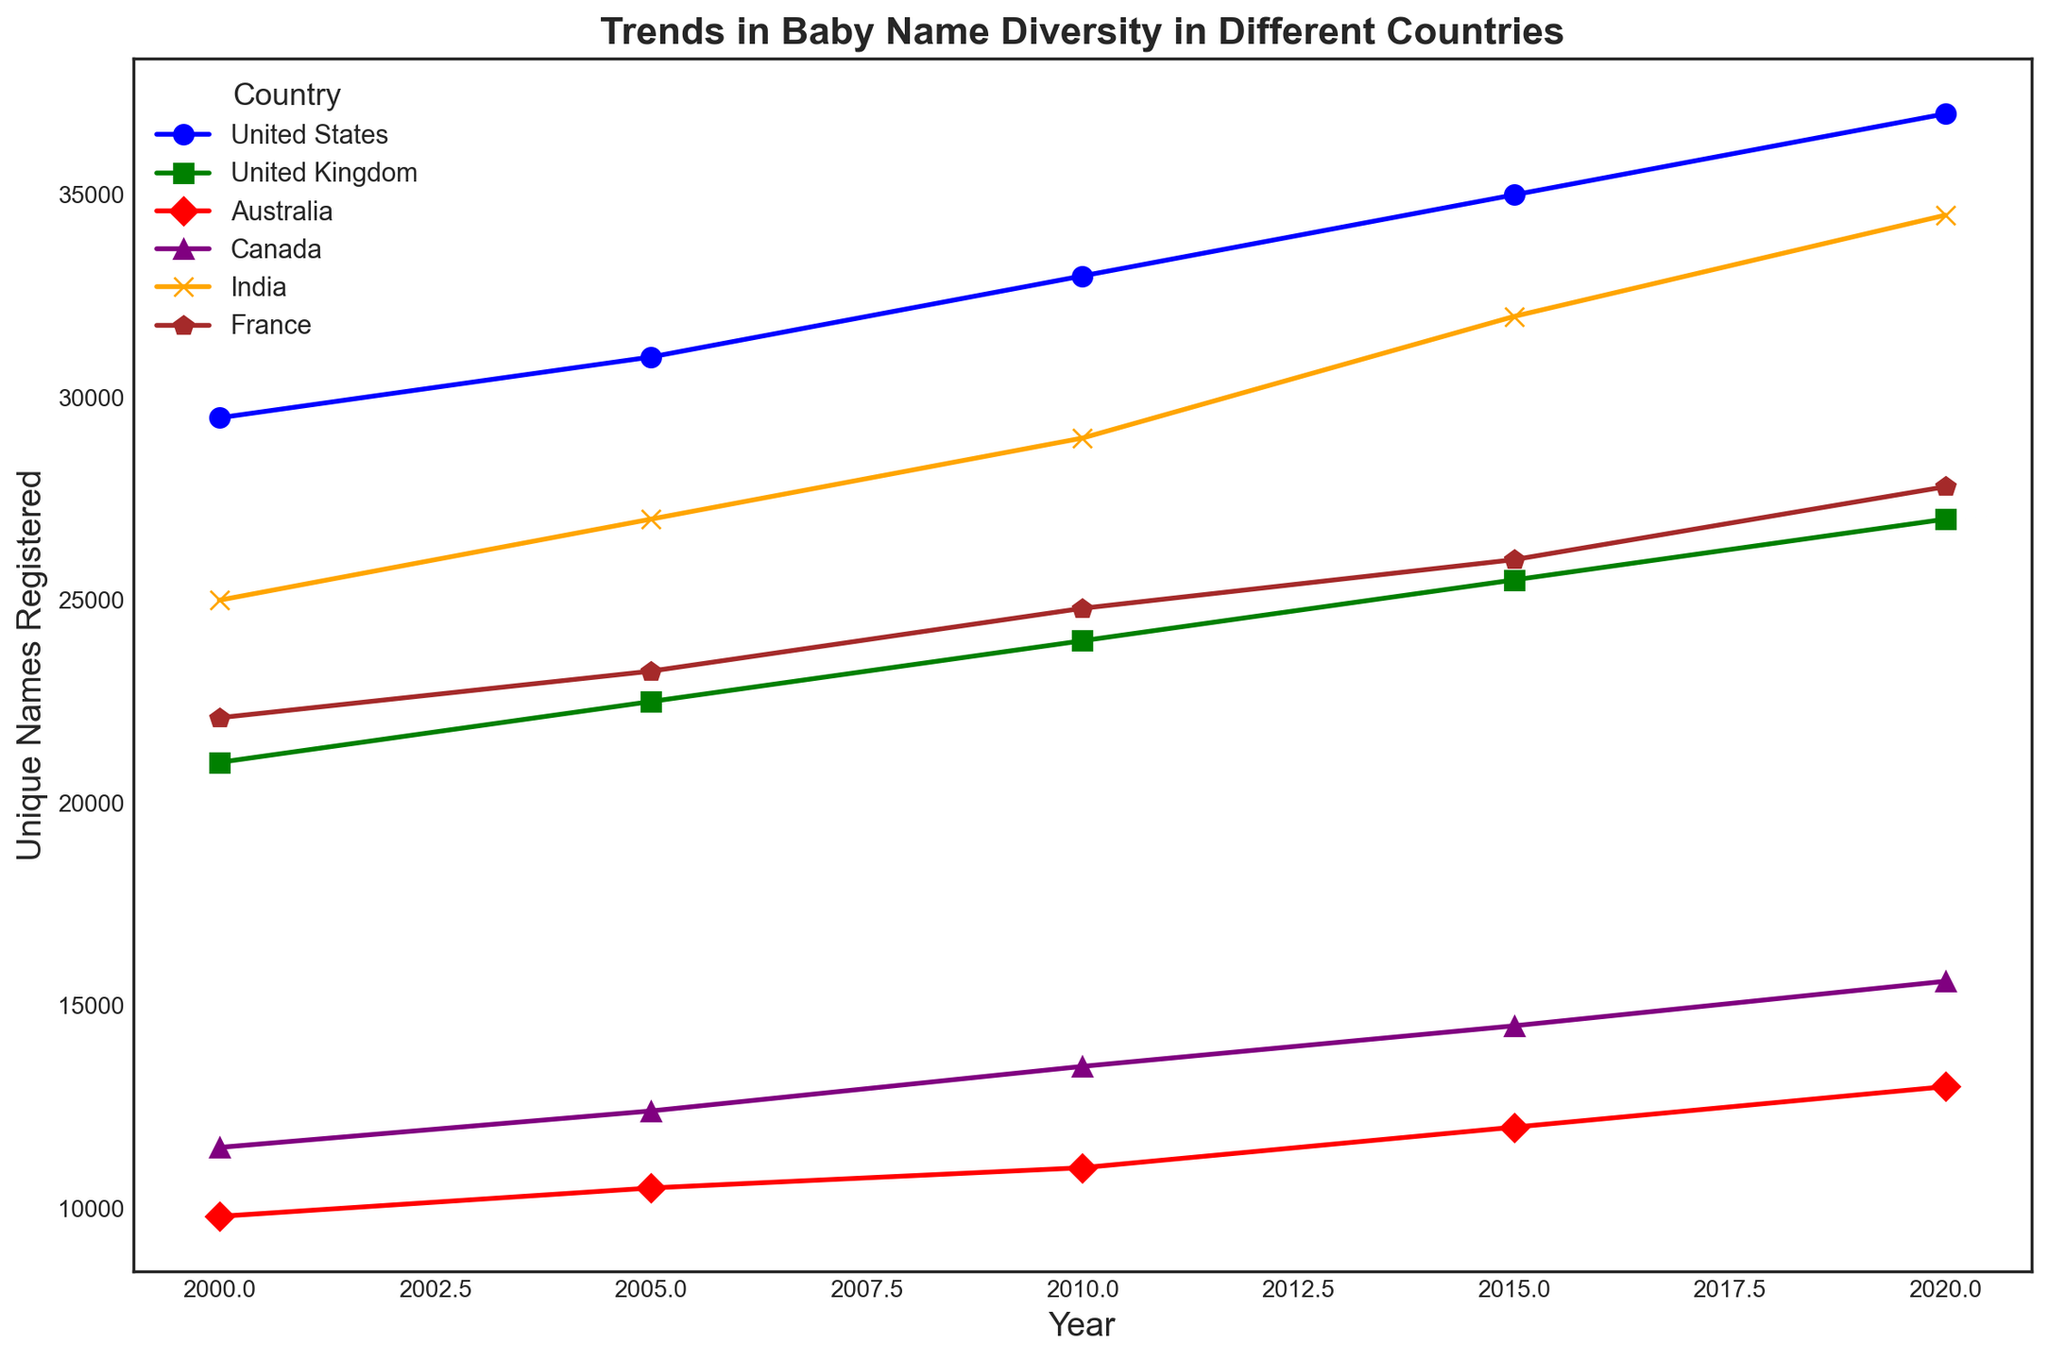Which country had the largest increase in unique names registered from 2000 to 2020? Look at the difference in unique names between 2000 and 2020 for each country. The United States increased by 7,500, the United Kingdom by 6,000, Australia by 3,200, Canada by 4,100, India by 9,500, and France by 5,700. India had the largest increase.
Answer: India Which country had the smallest number of unique names registered in 2020? Compare the values for unique names registered in 2020 for all countries. Australia has the smallest number with 13,000.
Answer: Australia By how much did the number of unique names in Canada increase from 2000 to 2015? Subtract the number of unique names in Canada for the year 2000 from the number in 2015 (14,500 - 11,500).
Answer: 3,000 Which country had more unique baby names registered in 2010, the United States or India? Compare the 2010 values for the United States and India. The United States had 33,000 and India had 29,000.
Answer: United States What is the average number of unique names registered in Australia over the five years shown? Add the unique names registered in Australia for the years 2000 (9,800), 2005 (10,500), 2010 (11,000), 2015 (12,000), and 2020 (13,000), then divide by 5 ((9,800 + 10,500 + 11,000 + 12,000 + 13,000) / 5).
Answer: 11,260 What pattern do you notice in the number of unique names registered in France over the different years? The number of unique names in France shows a consistent upward trend from 2000 (22,100) to 2020 (27,800).
Answer: Consistent upward trend Which country shows the most stable increase in the number of unique names from 2000 to 2020, both in terms of pattern and magnitude? Observe the slopes and consistency of the lines representing each country. Canada shows a stable and consistent increase in the number of unique names registered, with slightly increasing increments of roughly 1,000-1,500 in each five-year interval.
Answer: Canada 